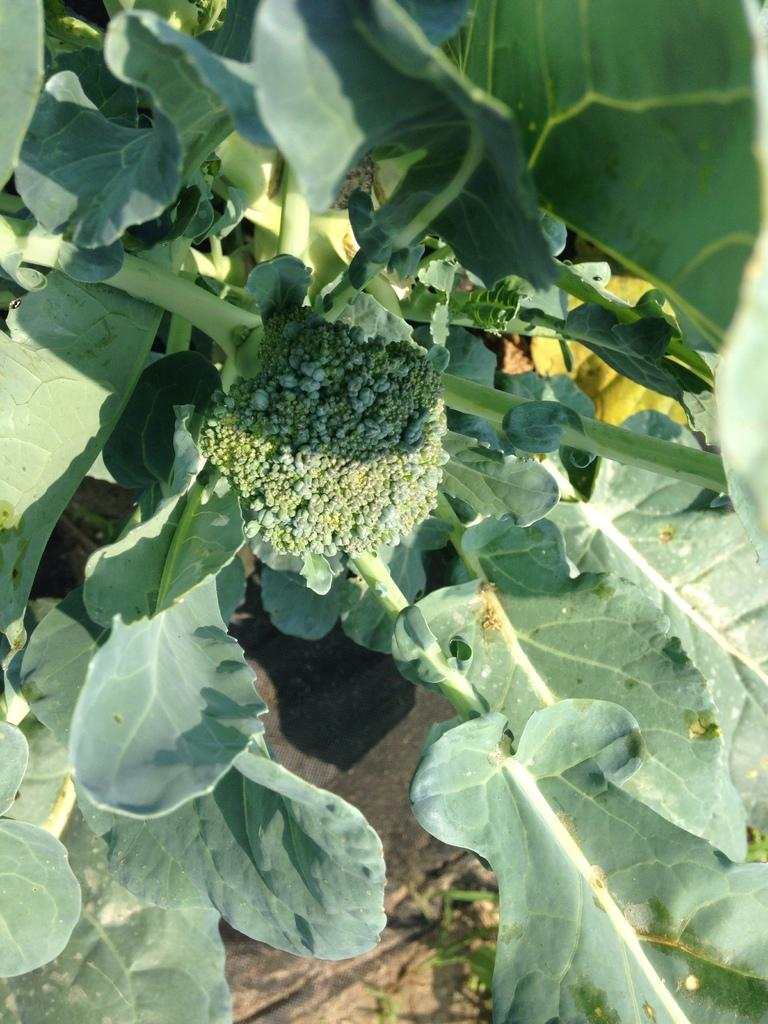What type of vegetation can be seen in the image? There are leaves in the image. Can you identify any specific plant in the image? Yes, there is a broccoli in the image. What type of attention is the broccoli receiving in the image? There is no indication in the image that the broccoli is receiving any specific type of attention. 